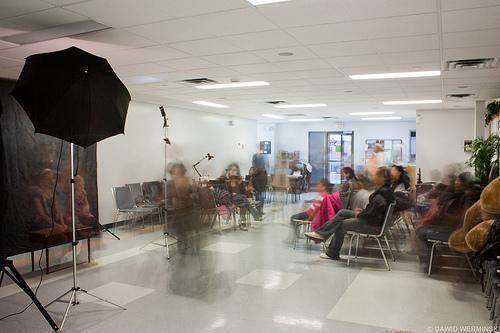How many screens in the photo?
Give a very brief answer. 1. 